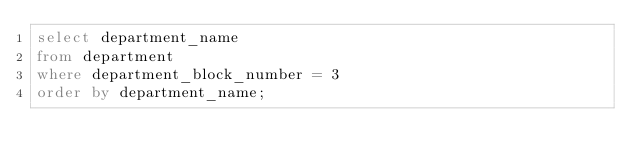<code> <loc_0><loc_0><loc_500><loc_500><_SQL_>select department_name
from department
where department_block_number = 3
order by department_name;</code> 